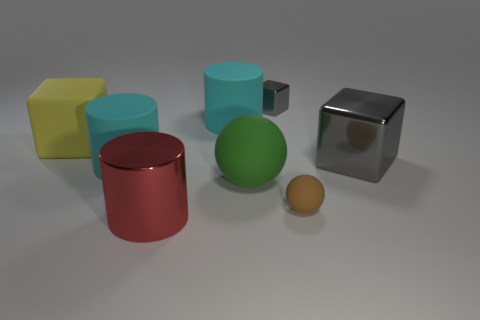Do the green thing and the tiny gray cube have the same material?
Your answer should be very brief. No. What shape is the gray thing on the left side of the rubber ball that is on the right side of the green matte object?
Your answer should be compact. Cube. What number of large green objects are behind the shiny thing that is behind the large gray metal cube?
Keep it short and to the point. 0. There is a large cylinder that is behind the small rubber ball and in front of the rubber block; what is it made of?
Offer a very short reply. Rubber. There is a gray metallic object that is the same size as the matte cube; what is its shape?
Offer a terse response. Cube. What color is the cylinder in front of the green matte ball behind the big metal object that is in front of the tiny brown ball?
Your answer should be very brief. Red. How many things are large metal things that are left of the tiny brown thing or large cylinders?
Offer a terse response. 3. What is the material of the gray block that is the same size as the green matte ball?
Make the answer very short. Metal. What is the material of the large cyan object on the left side of the cyan rubber object that is behind the gray shiny block in front of the tiny block?
Offer a very short reply. Rubber. What is the color of the big ball?
Ensure brevity in your answer.  Green. 